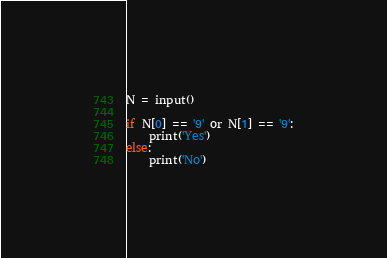Convert code to text. <code><loc_0><loc_0><loc_500><loc_500><_Python_>N = input()

if N[0] == '9' or N[1] == '9':
    print('Yes')
else:
    print('No')</code> 